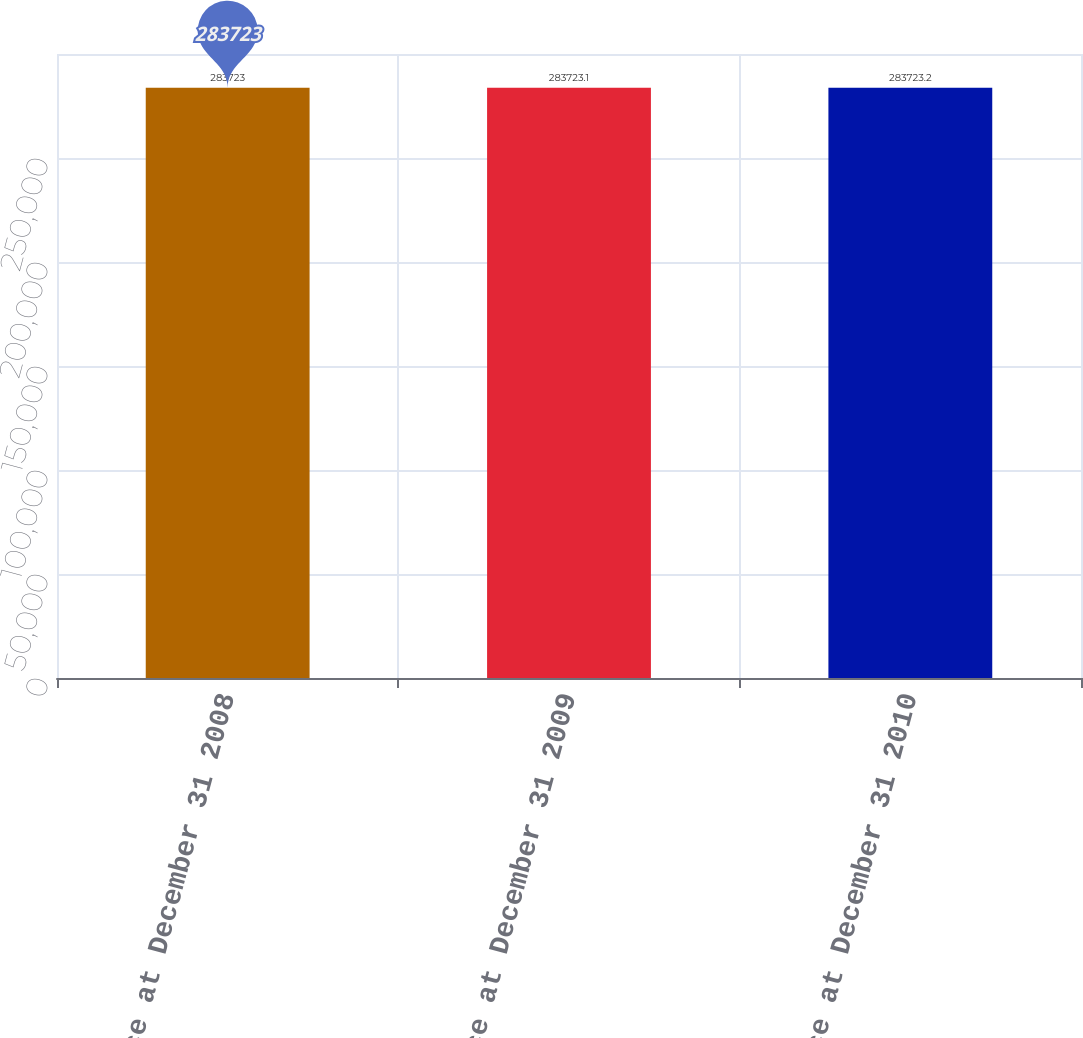Convert chart. <chart><loc_0><loc_0><loc_500><loc_500><bar_chart><fcel>Balance at December 31 2008<fcel>Balance at December 31 2009<fcel>Balance at December 31 2010<nl><fcel>283723<fcel>283723<fcel>283723<nl></chart> 